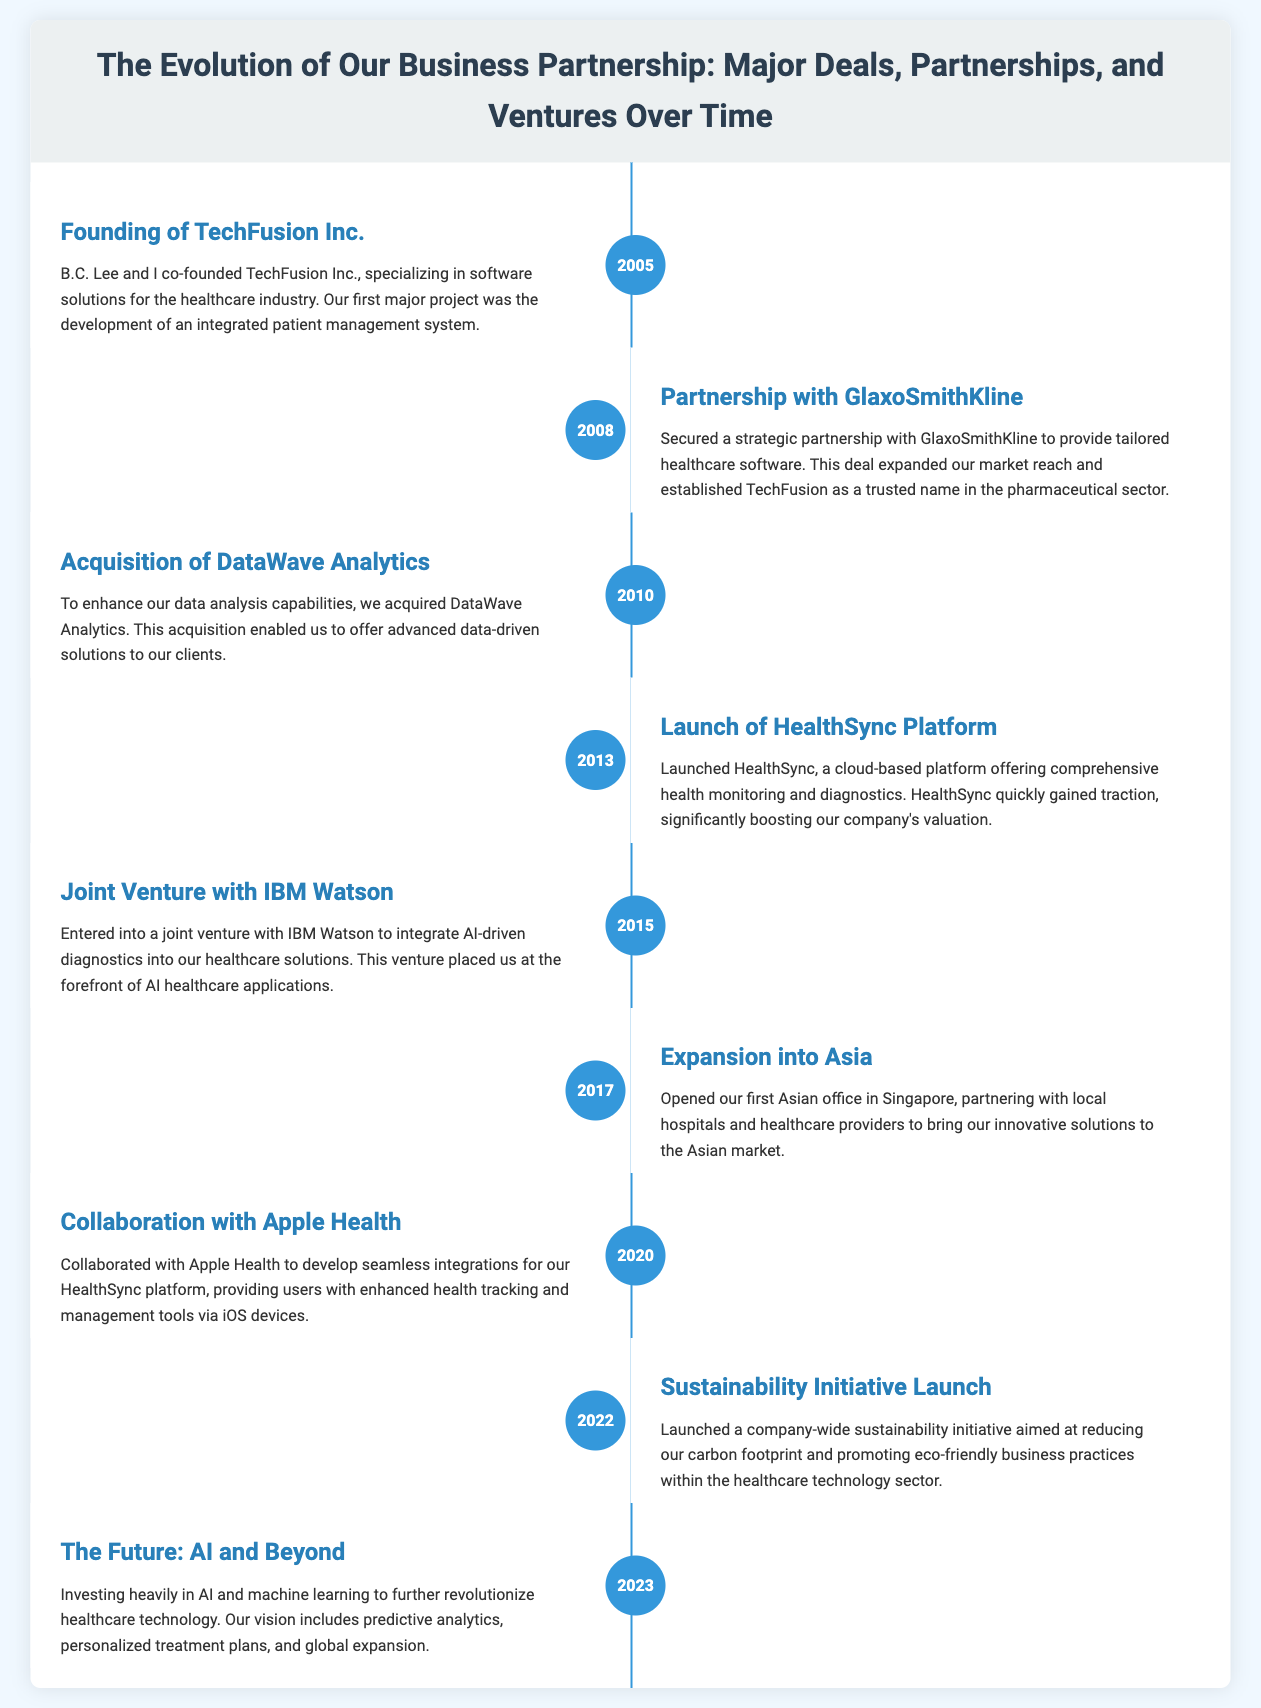What year was TechFusion Inc. founded? The founding year is explicitly stated in the document under the first event.
Answer: 2005 Which major partnership was formed in 2008? The document specifies the partnership formed with GlaxoSmithKline during the second event.
Answer: GlaxoSmithKline What significant acquisition occurred in 2010? The acquisition of DataWave Analytics is mentioned in the third event.
Answer: DataWave Analytics What product was launched in 2013? The event details the launch of the HealthSync platform in 2013.
Answer: HealthSync What was the focus of the 2015 joint venture? The document describes the purpose of the joint venture, which involved integrating AI-driven diagnostics.
Answer: AI-driven diagnostics How many years apart were the founding of TechFusion Inc. and the launch of the HealthSync platform? To find the difference, subtract the years of founding and launching: 2013 - 2005.
Answer: 8 What initiative was launched in 2022? The document outlines the sustainability initiative started in 2022.
Answer: Sustainability Initiative What is the vision for the future as stated in 2023? The future vision discussed the focus on AI and machine learning to revolutionize healthcare technology.
Answer: AI and machine learning What role did Singapore play in 2017? The document mentions the opening of the first Asian office in Singapore, indicating its importance.
Answer: First Asian office 